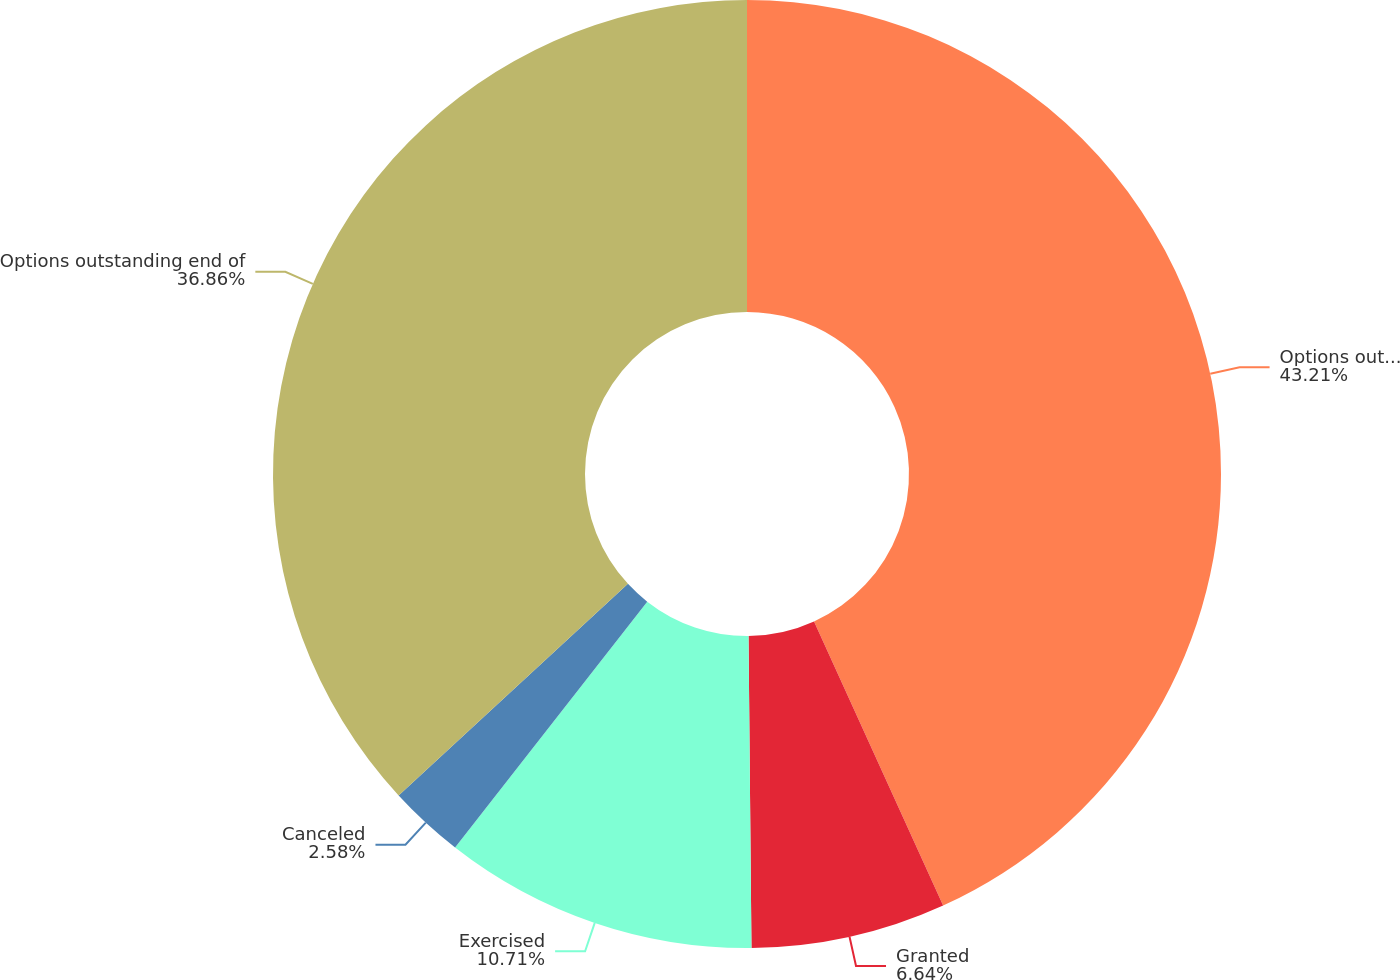Convert chart. <chart><loc_0><loc_0><loc_500><loc_500><pie_chart><fcel>Options outstanding beginning<fcel>Granted<fcel>Exercised<fcel>Canceled<fcel>Options outstanding end of<nl><fcel>43.21%<fcel>6.64%<fcel>10.71%<fcel>2.58%<fcel>36.86%<nl></chart> 